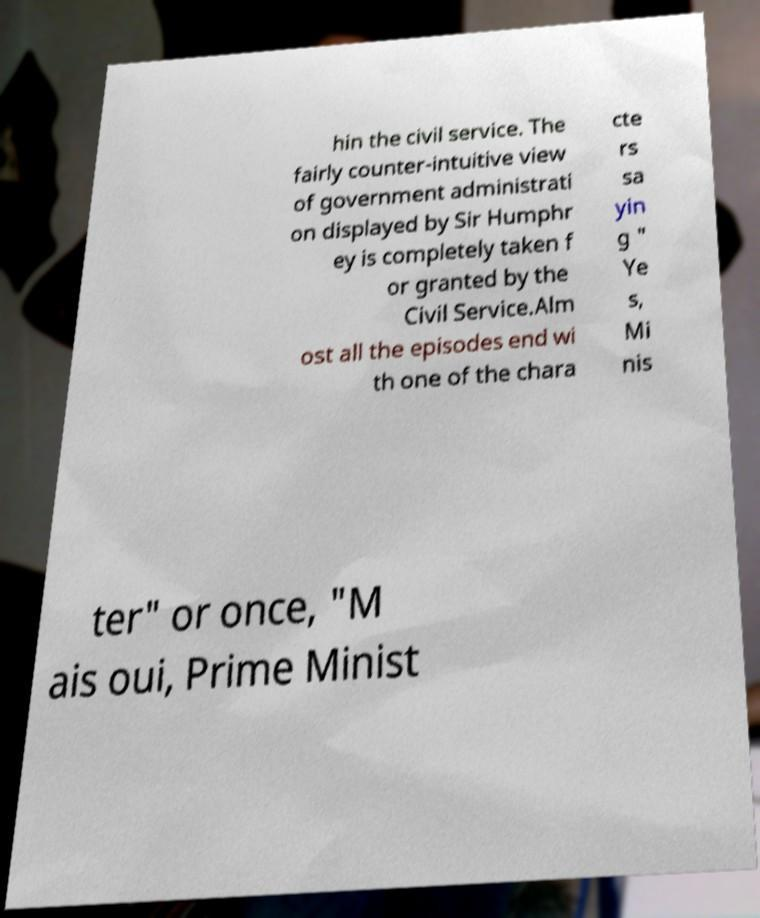What messages or text are displayed in this image? I need them in a readable, typed format. hin the civil service. The fairly counter-intuitive view of government administrati on displayed by Sir Humphr ey is completely taken f or granted by the Civil Service.Alm ost all the episodes end wi th one of the chara cte rs sa yin g " Ye s, Mi nis ter" or once, "M ais oui, Prime Minist 